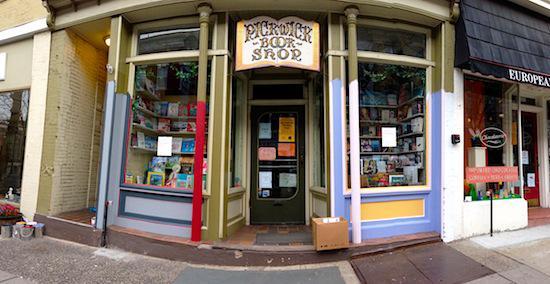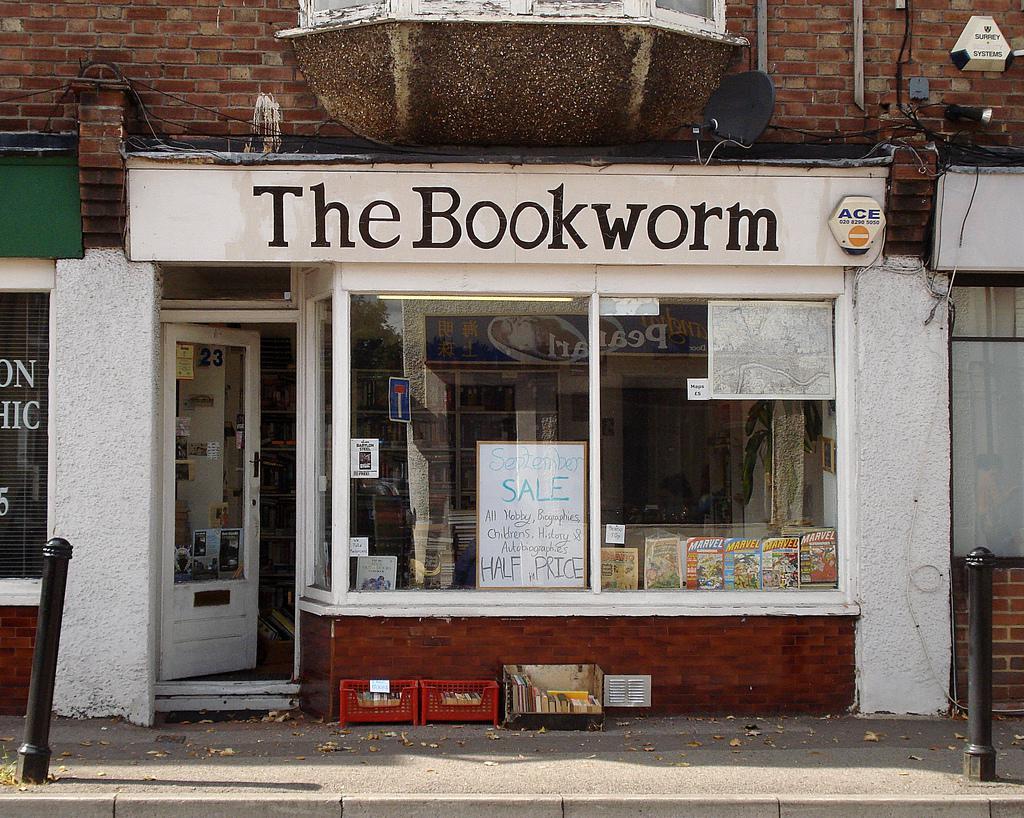The first image is the image on the left, the second image is the image on the right. Considering the images on both sides, is "Each image is of the sidewalk exterior of a bookstore, one with the front door standing open and one with the front door closed." valid? Answer yes or no. Yes. The first image is the image on the left, the second image is the image on the right. Assess this claim about the two images: "There are people sitting.". Correct or not? Answer yes or no. No. 